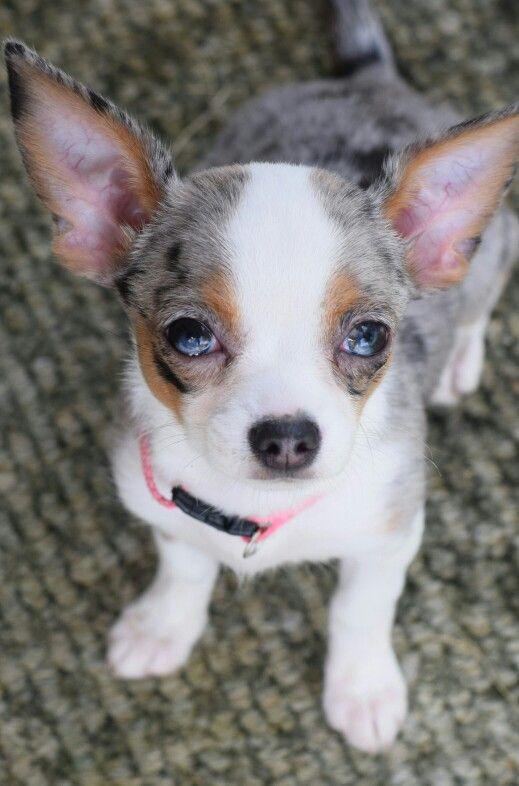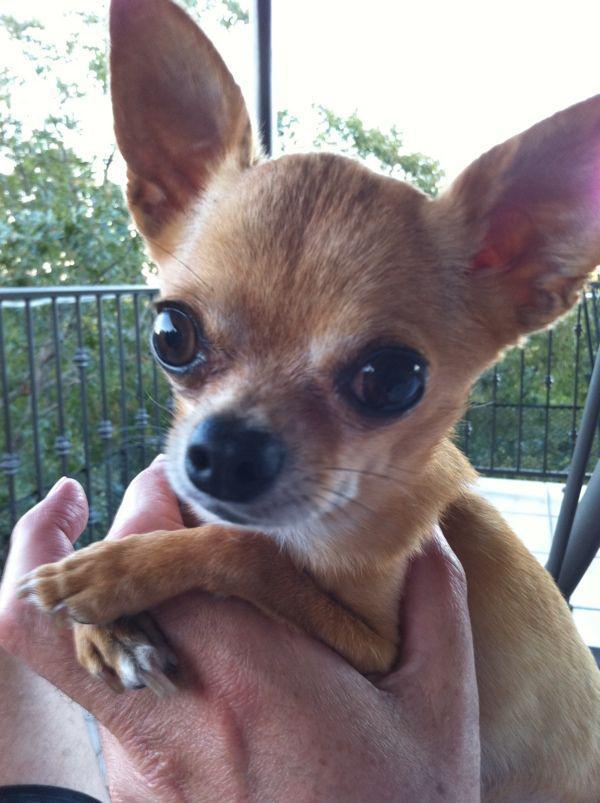The first image is the image on the left, the second image is the image on the right. Evaluate the accuracy of this statement regarding the images: "An image shows a dog with its tongue sticking out.". Is it true? Answer yes or no. No. The first image is the image on the left, the second image is the image on the right. Examine the images to the left and right. Is the description "One of the dogs has its tongue sticking out." accurate? Answer yes or no. No. The first image is the image on the left, the second image is the image on the right. For the images shown, is this caption "Two little dogs have eyes wide open, but only one of them is showing his tongue." true? Answer yes or no. No. The first image is the image on the left, the second image is the image on the right. Considering the images on both sides, is "One of the images shows a dog with its tongue sticking out." valid? Answer yes or no. No. 